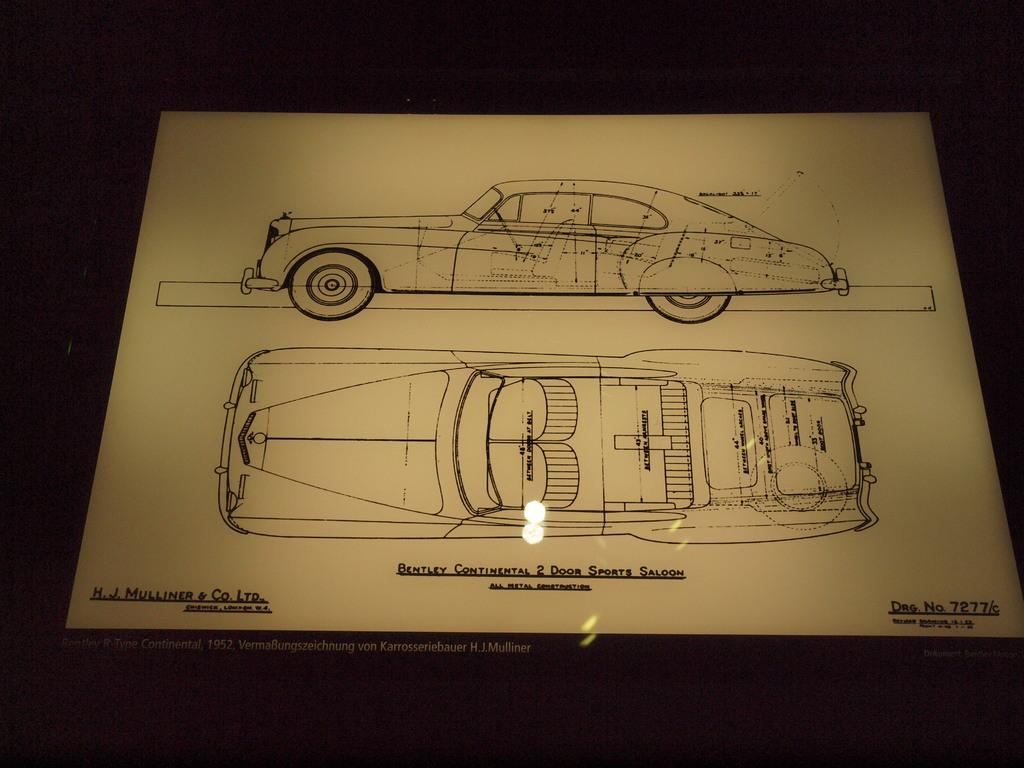What is the main subject of the paper in the image? The paper contains car diagrams. What type of information is present on the paper? There is text on the paper. How many geese are visible in the image? There are no geese present in the image. What type of yam is being used to illustrate the car diagrams? The image does not contain any yams, and the car diagrams are not related to yams. 